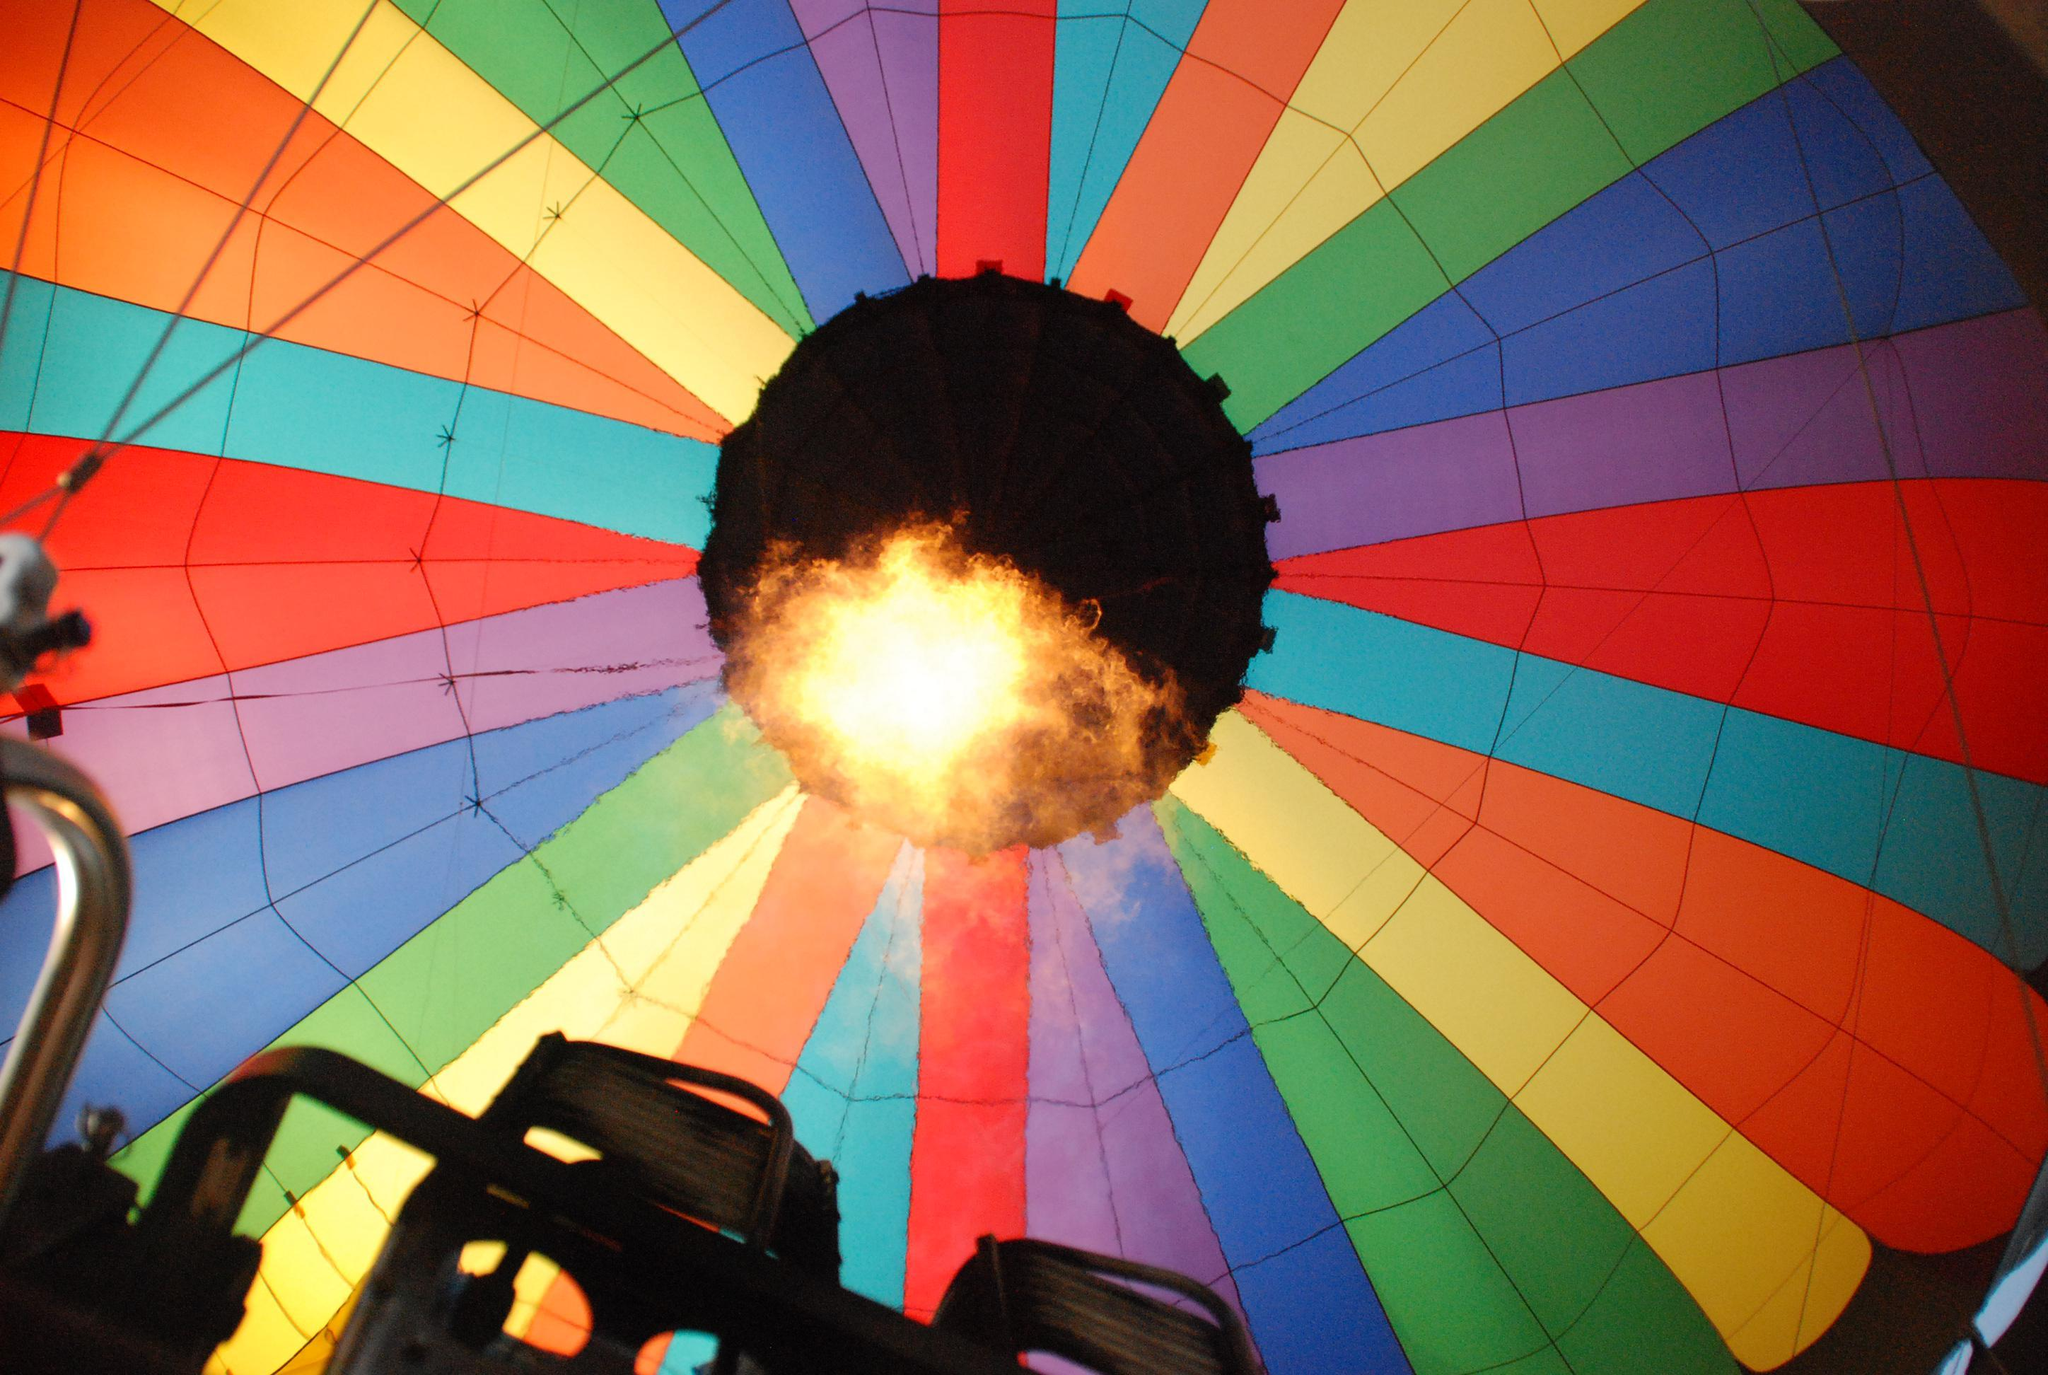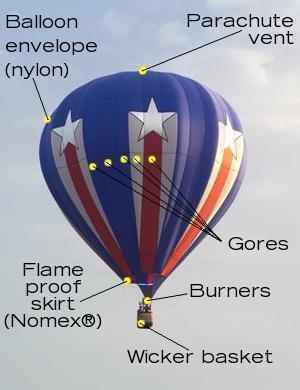The first image is the image on the left, the second image is the image on the right. For the images displayed, is the sentence "An image shows the bright light of a flame inside a multi-colored hot-air balloon." factually correct? Answer yes or no. Yes. 